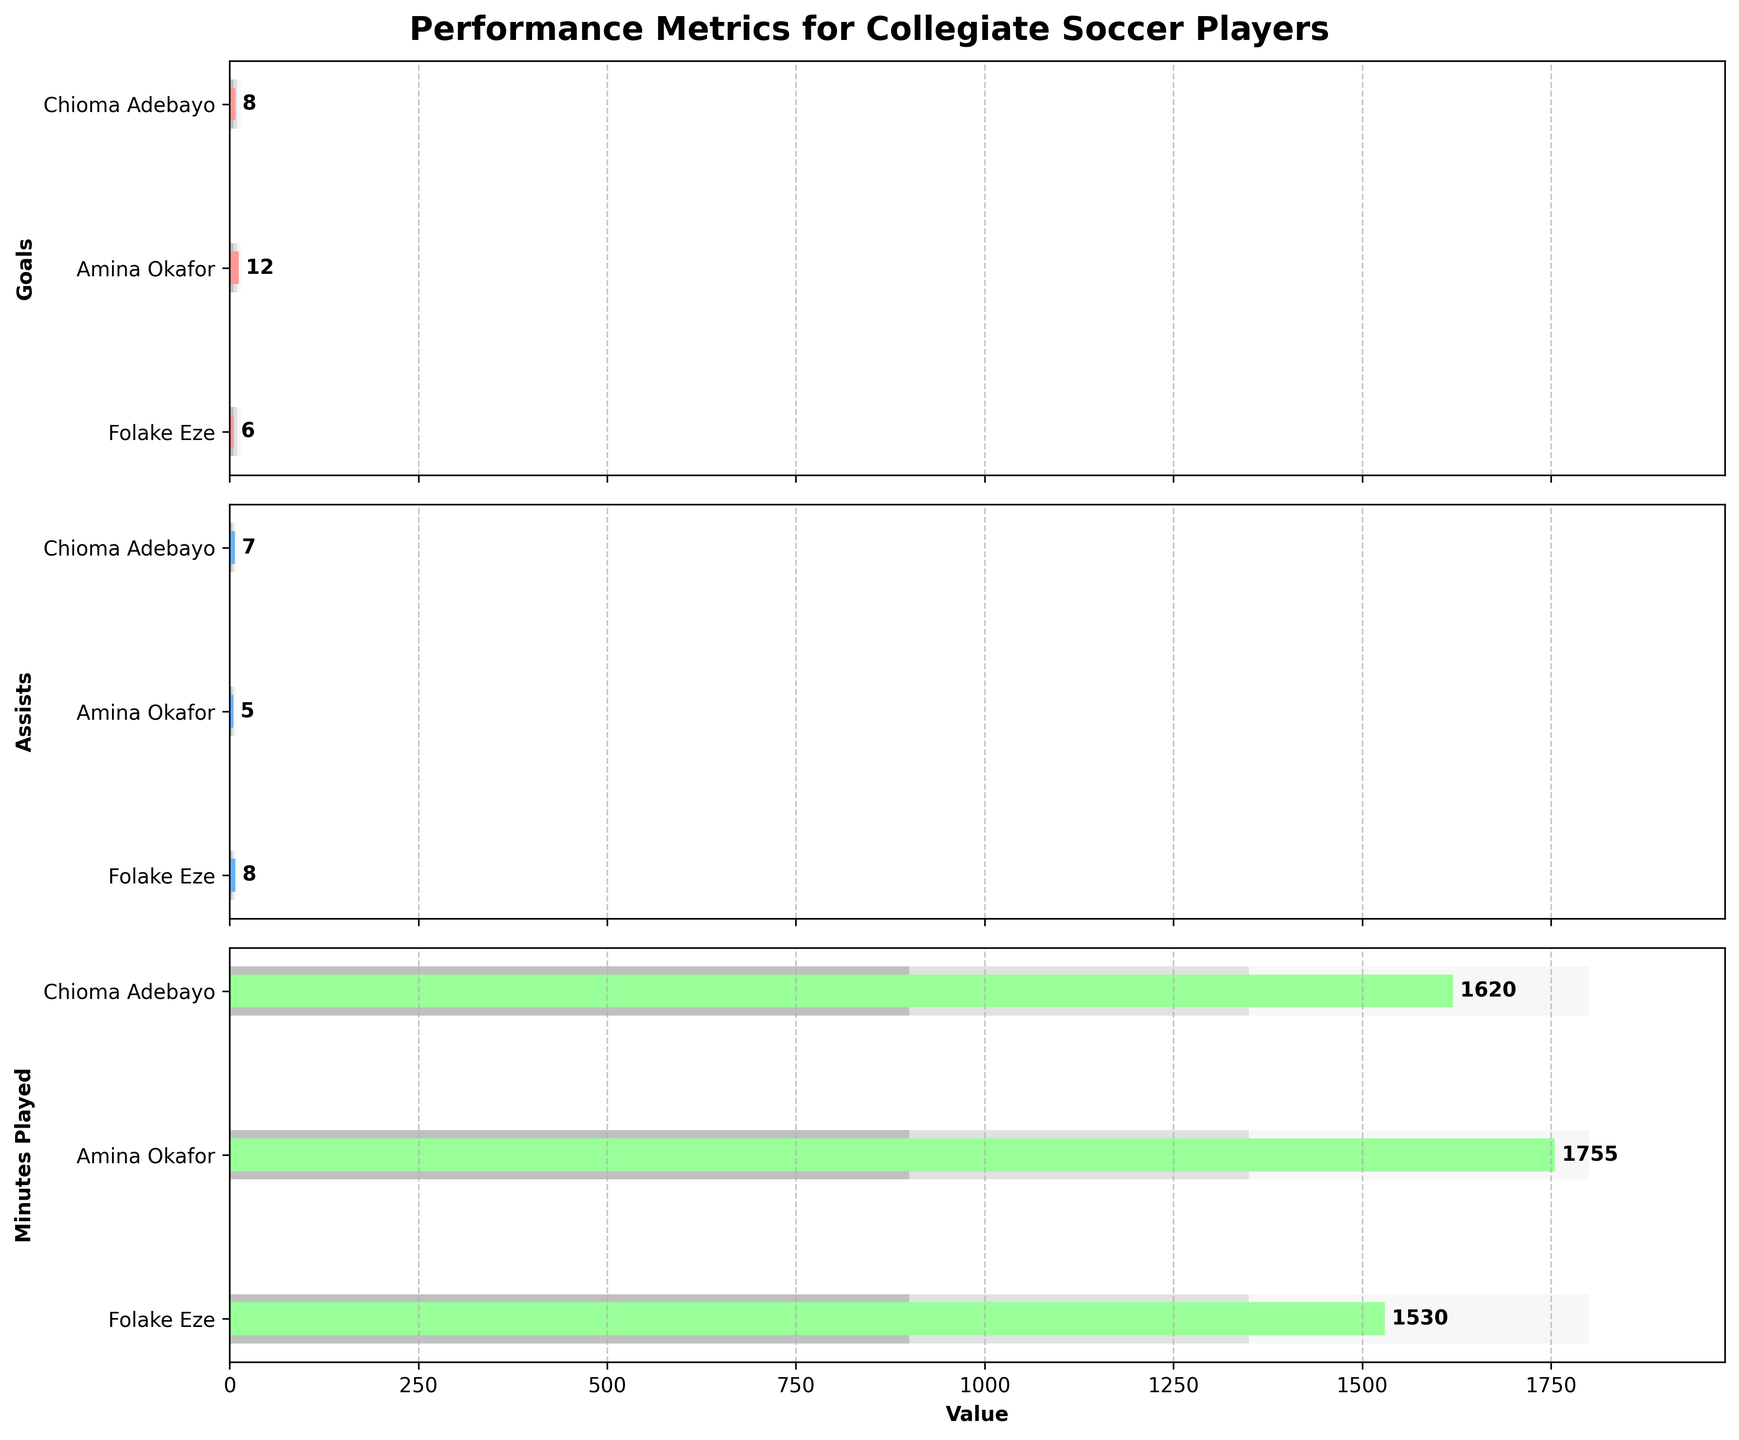what is the actual number of goals scored by Chioma Adebayo? Chioma Adebayo's actual performance for goals can be seen in the bullet chart for the "Goals" metric. The value is represented by a solid color bar. According to the figure, the actual number is indicated next to the bar.
Answer: 8 How many minutes did Amina Okafor play compared to Chioma Adebayo? We need to compare the "Minutes Played" bars for both players. Amina Okafor's actual minutes are next to her bar, which is 1755, and Chioma Adebayo's actual minutes are 1620. Subtract Chioma's value from Amina's.
Answer: 135 Which player has the highest number of assists? Check the "Assists" bars for all players. The actual values are represented by solid color bars with their counts shown next to them. Compare Chioma Adebayo's 7, Amina Okafor's 5, and Folake Eze's 8.
Answer: Folake Eze Is Chioma Adebayo’s performance for minutes played rated as 'Good'? The rating levels (Poor, Average, Good, Very Good) are represented by different shades of bars. Check where Chioma Adebayo's "Minutes Played" bar (1620) falls within these ranges. 1620 lies between 1350 (Good) and 1800 (Very Good).
Answer: Yes What is the total number of goals scored by all players? To find the total, add the actual goals scored by Chioma Adebayo, Amina Okafor, and Folake Eze. According to the figure, the values are 8, 12, and 6, respectively. Add these numbers together.
Answer: 26 Who has the least number of minutes played? Compare the "Minutes Played" bars. The actual values are next to the bars for Chioma Adebayo (1620), Amina Okafor (1755), and Folake Eze (1530). The smallest value among these is for Folake Eze.
Answer: Folake Eze How does Amina Okafor's assist performance compare to the "Very Good" benchmark? On the "Assists" bullet chart, Amina Okafor's actual assist count is 5. The "Very Good" benchmark is represented by the farthest shaded bar, which is 9. Amina's value is less than this benchmark.
Answer: Less than What’s the difference between the number of goals scored by Chioma Adebayo and Amina Okafor? Check the "Goals" metric bars for both players. Chioma Adebayo has 8 while Amina Okafor has 12. Subtract Chioma's goals from Amina's.
Answer: 4 